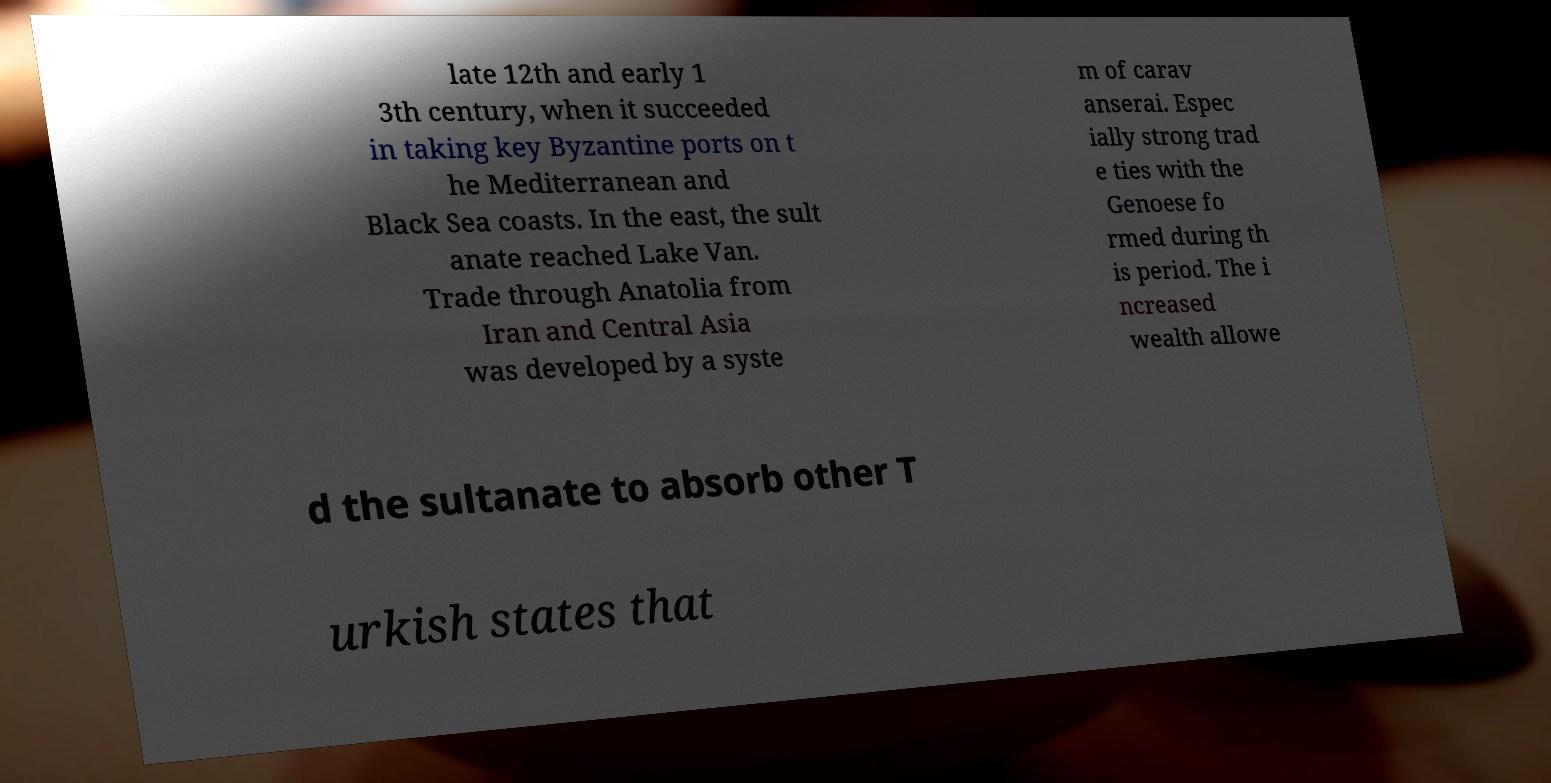There's text embedded in this image that I need extracted. Can you transcribe it verbatim? late 12th and early 1 3th century, when it succeeded in taking key Byzantine ports on t he Mediterranean and Black Sea coasts. In the east, the sult anate reached Lake Van. Trade through Anatolia from Iran and Central Asia was developed by a syste m of carav anserai. Espec ially strong trad e ties with the Genoese fo rmed during th is period. The i ncreased wealth allowe d the sultanate to absorb other T urkish states that 